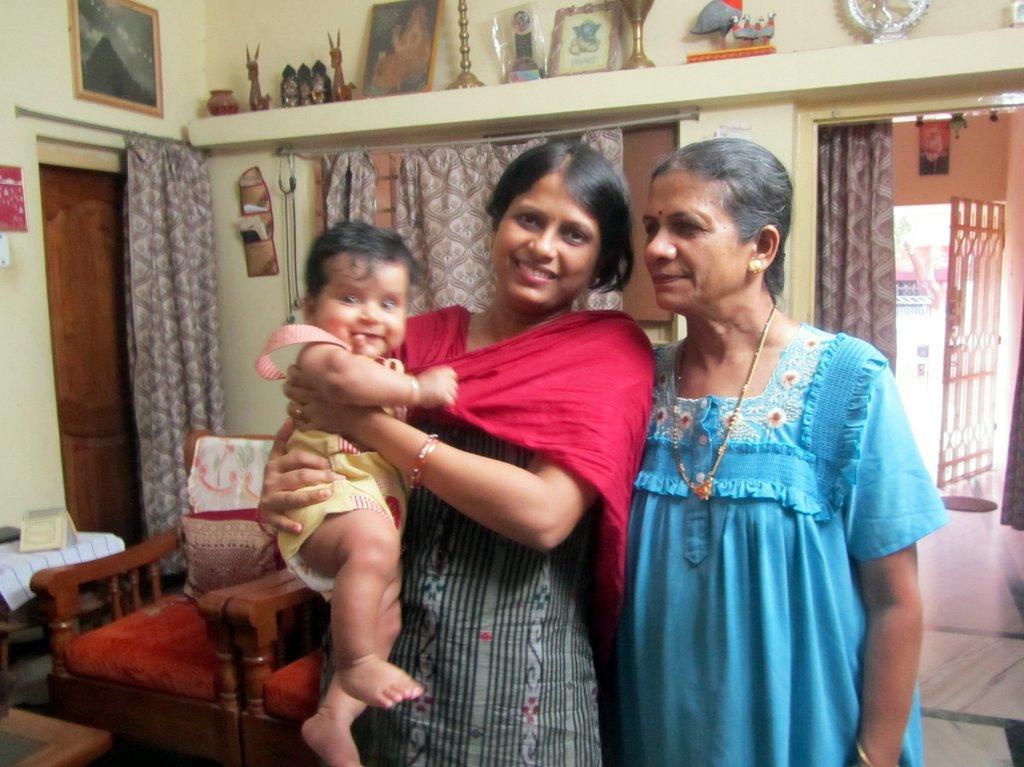Describe this image in one or two sentences. In this image I see 2 women and one of this woman is holding the baby, In the background 2 sofas, a door, the wall and few things on the rack. 